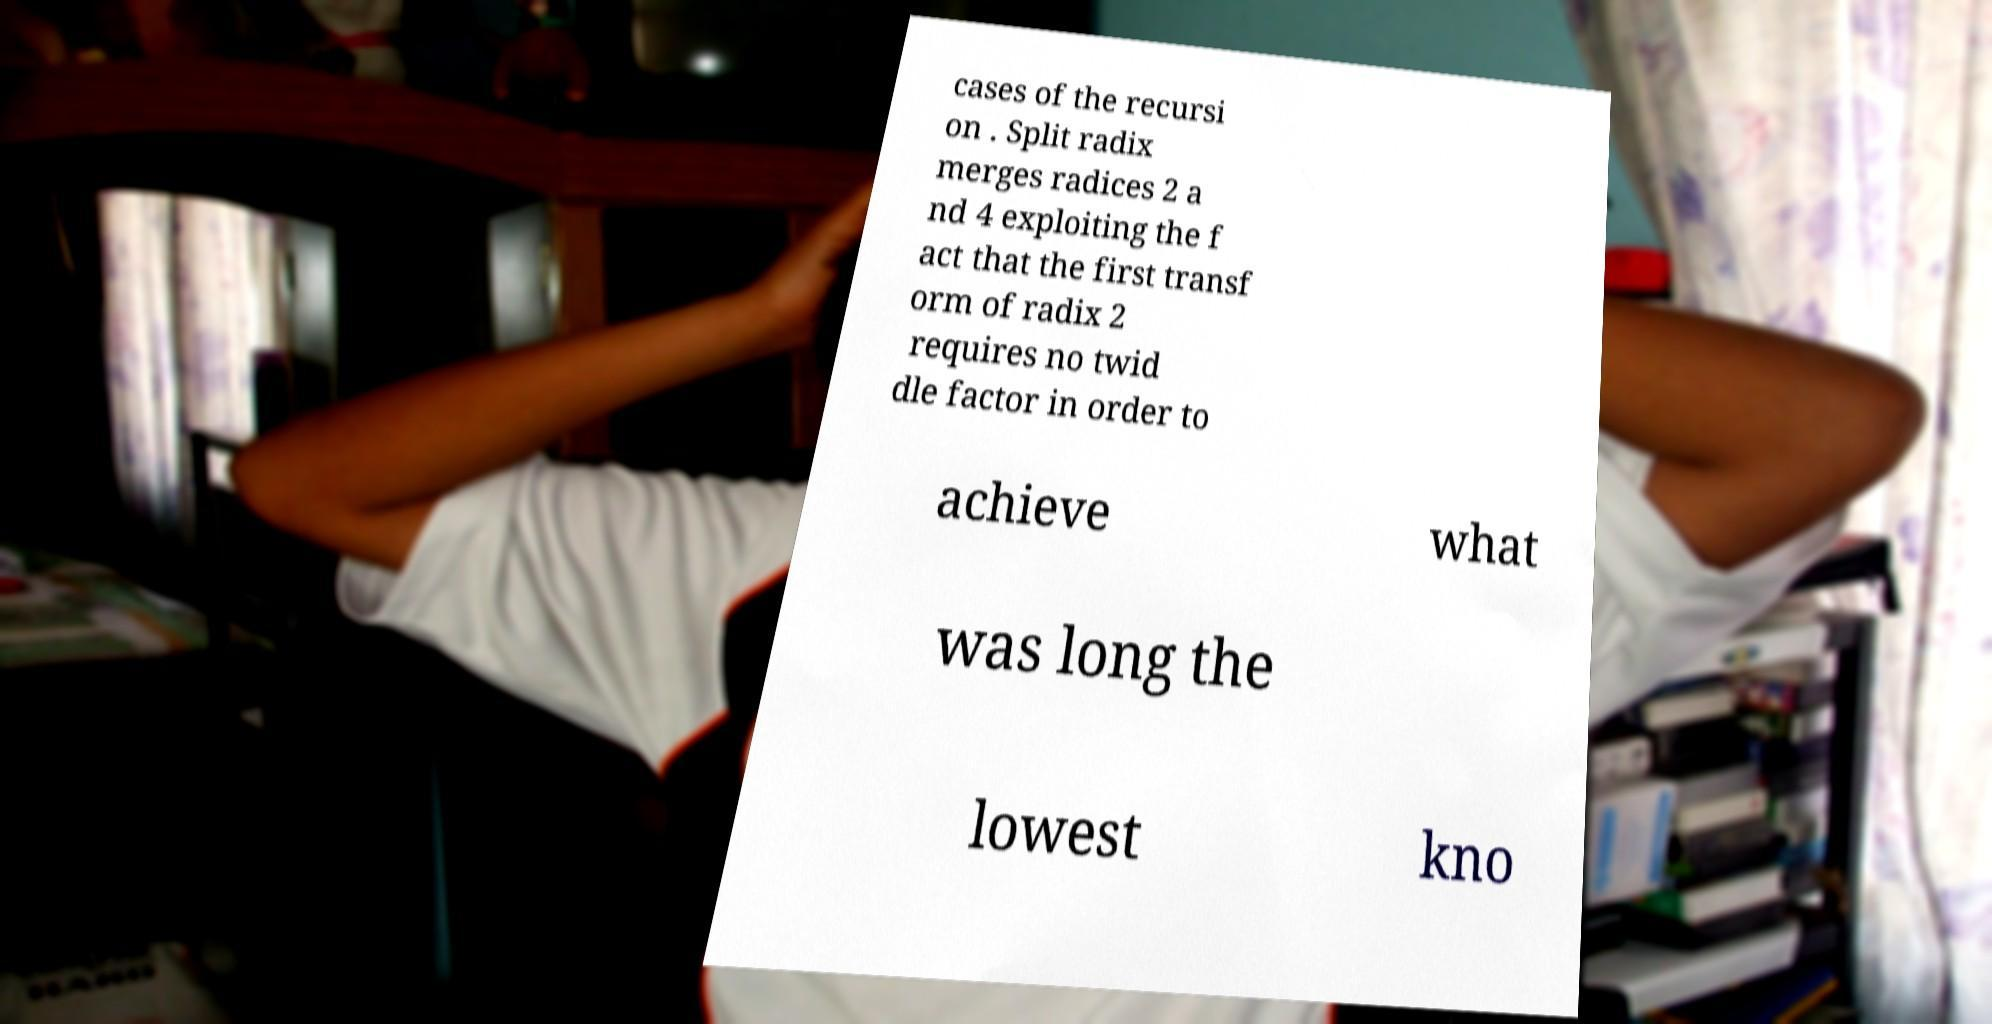What messages or text are displayed in this image? I need them in a readable, typed format. cases of the recursi on . Split radix merges radices 2 a nd 4 exploiting the f act that the first transf orm of radix 2 requires no twid dle factor in order to achieve what was long the lowest kno 